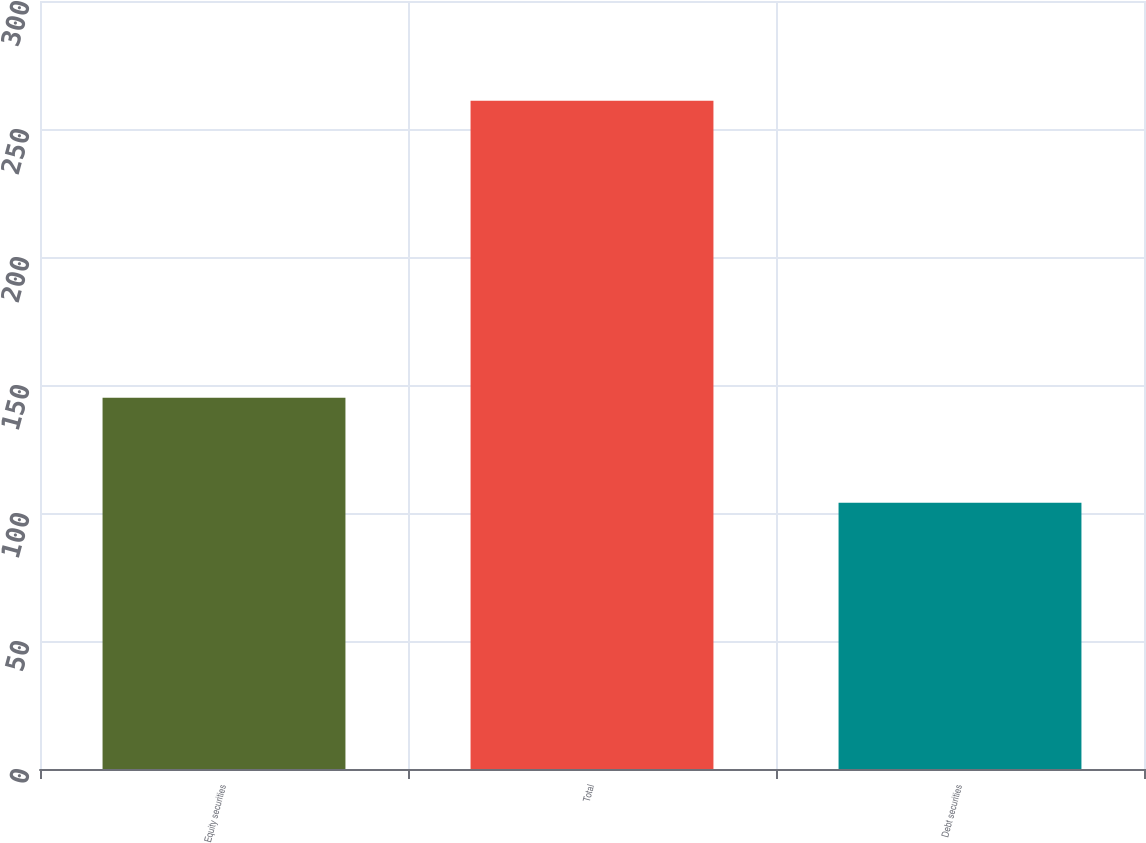Convert chart to OTSL. <chart><loc_0><loc_0><loc_500><loc_500><bar_chart><fcel>Equity securities<fcel>Total<fcel>Debt securities<nl><fcel>145<fcel>261<fcel>104<nl></chart> 